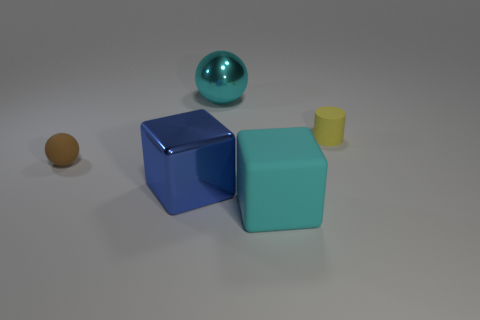Add 2 brown rubber spheres. How many objects exist? 7 Subtract all cubes. How many objects are left? 3 Add 3 blue things. How many blue things exist? 4 Subtract 0 green cylinders. How many objects are left? 5 Subtract all big cyan matte blocks. Subtract all purple cylinders. How many objects are left? 4 Add 3 metal cubes. How many metal cubes are left? 4 